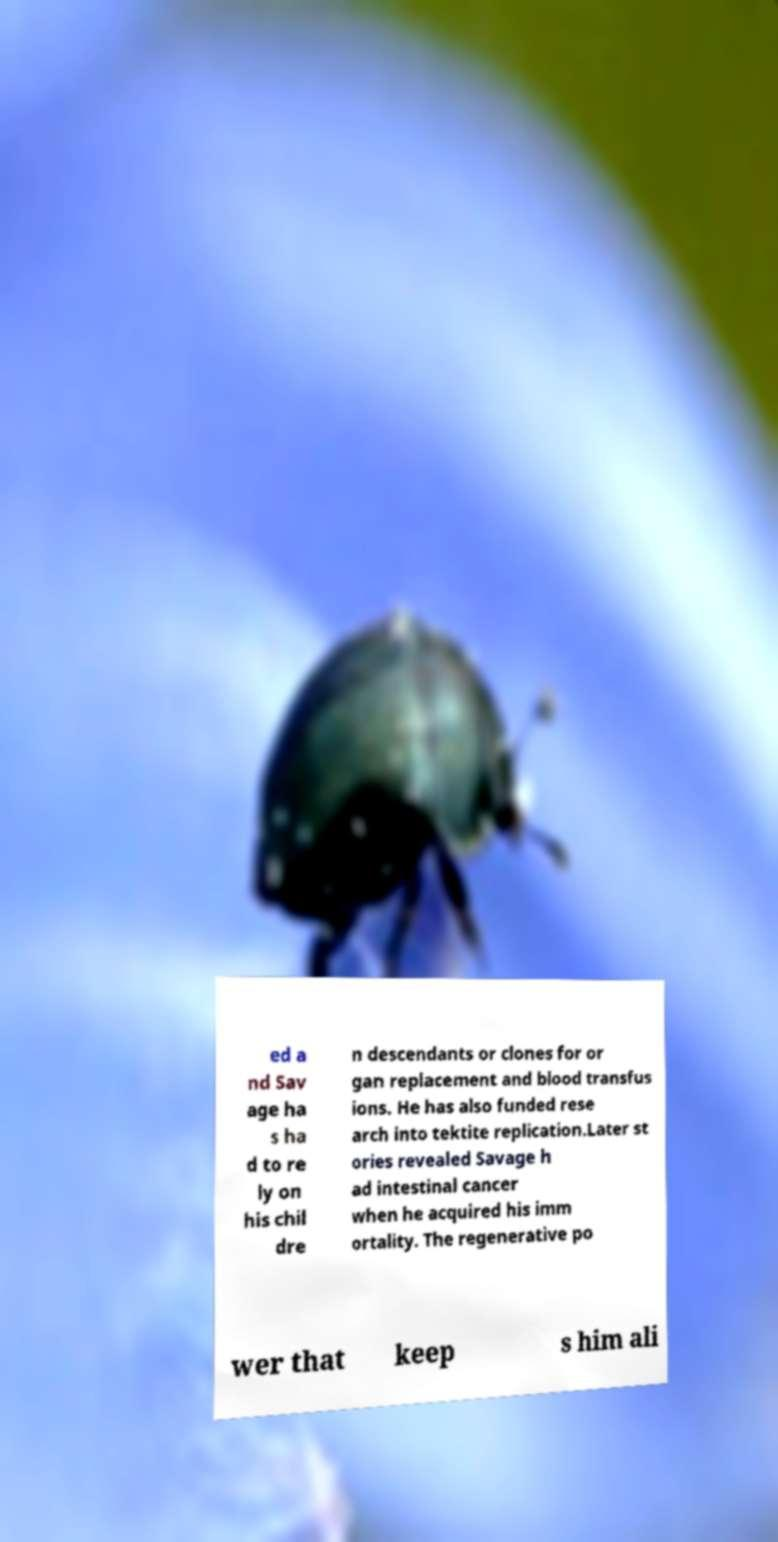There's text embedded in this image that I need extracted. Can you transcribe it verbatim? ed a nd Sav age ha s ha d to re ly on his chil dre n descendants or clones for or gan replacement and blood transfus ions. He has also funded rese arch into tektite replication.Later st ories revealed Savage h ad intestinal cancer when he acquired his imm ortality. The regenerative po wer that keep s him ali 